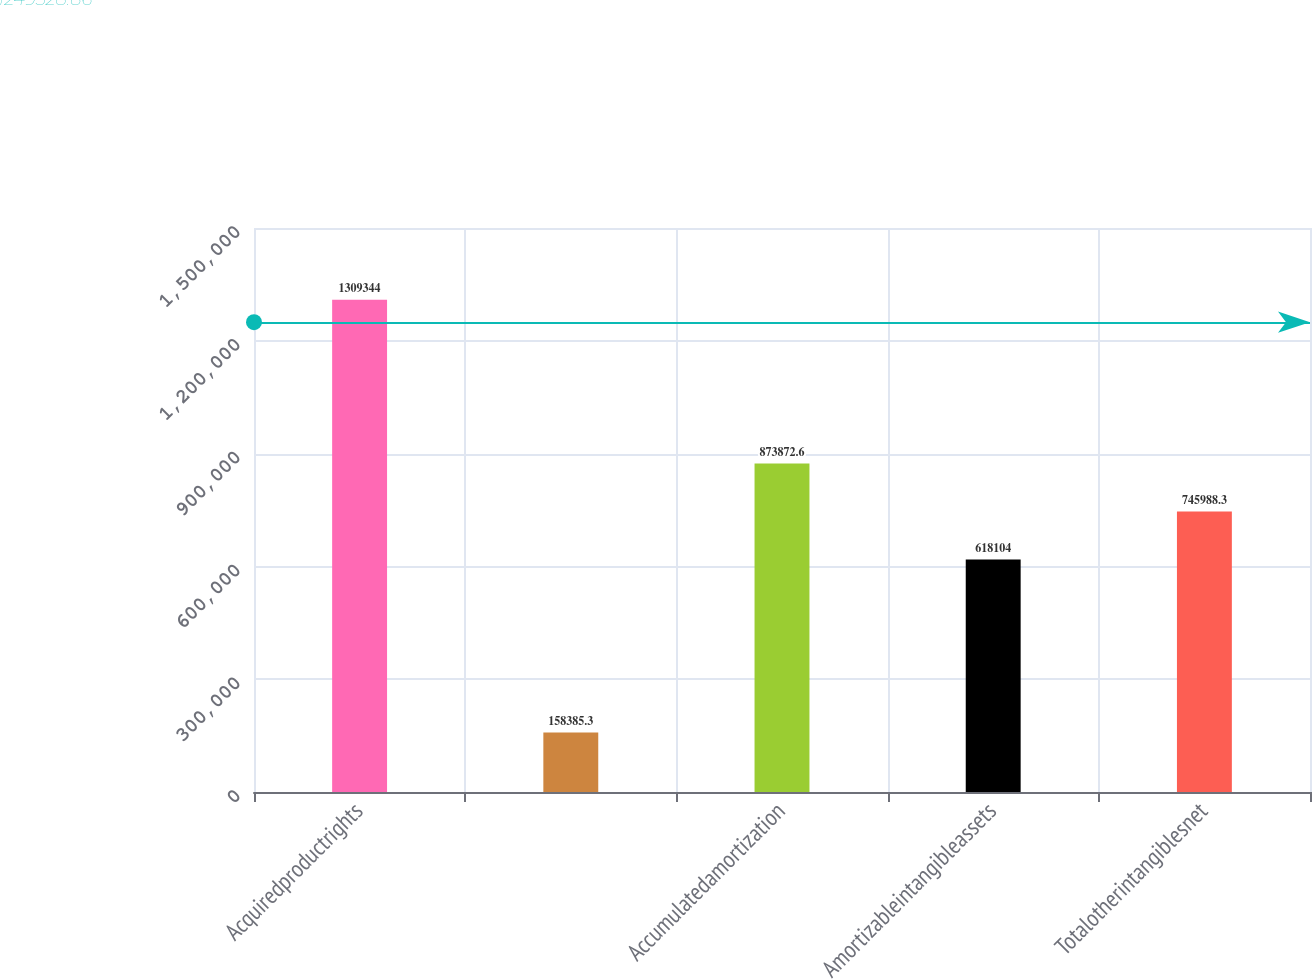<chart> <loc_0><loc_0><loc_500><loc_500><bar_chart><fcel>Acquiredproductrights<fcel>Unnamed: 1<fcel>Accumulatedamortization<fcel>Amortizableintangibleassets<fcel>Totalotherintangiblesnet<nl><fcel>1.30934e+06<fcel>158385<fcel>873873<fcel>618104<fcel>745988<nl></chart> 